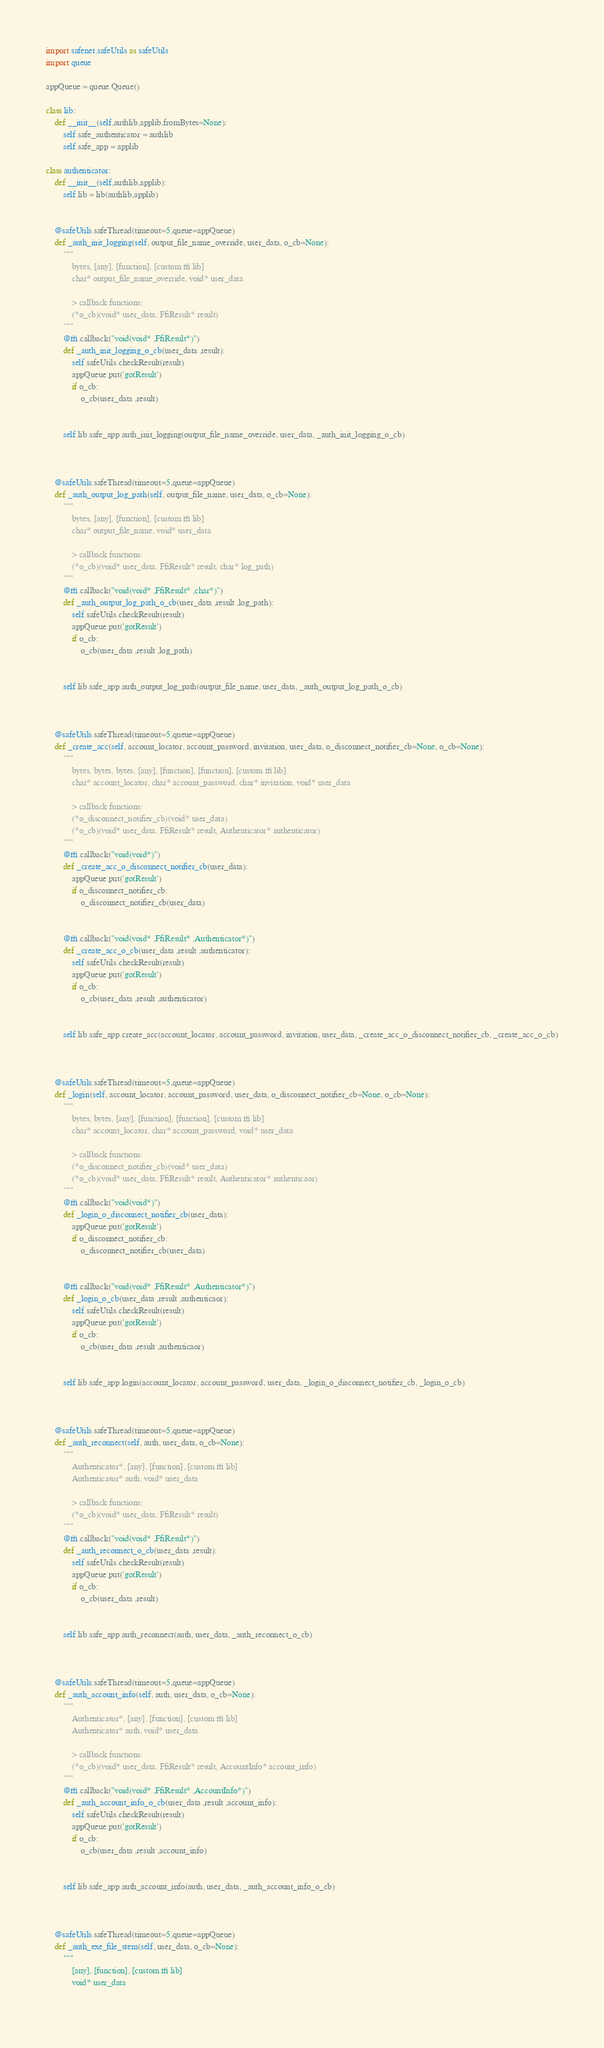<code> <loc_0><loc_0><loc_500><loc_500><_Python_>import safenet.safeUtils as safeUtils
import queue

appQueue = queue.Queue()

class lib:
    def __init__(self,authlib,applib,fromBytes=None):
        self.safe_authenticator = authlib
        self.safe_app = applib

class authenticator:
    def __init__(self,authlib,applib):
        self.lib = lib(authlib,applib)


    @safeUtils.safeThread(timeout=5,queue=appQueue)
    def _auth_init_logging(self, output_file_name_override, user_data, o_cb=None):
        """
            bytes, [any], [function], [custom ffi lib]
            char* output_file_name_override, void* user_data
    
            > callback functions:
            (*o_cb)(void* user_data, FfiResult* result)
        """
        @ffi.callback("void(void* ,FfiResult*)")
        def _auth_init_logging_o_cb(user_data ,result):
            self.safeUtils.checkResult(result)
            appQueue.put('gotResult')
            if o_cb:
                o_cb(user_data ,result)
    
    
        self.lib.safe_app.auth_init_logging(output_file_name_override, user_data, _auth_init_logging_o_cb)
    
    
    
    @safeUtils.safeThread(timeout=5,queue=appQueue)
    def _auth_output_log_path(self, output_file_name, user_data, o_cb=None):
        """
            bytes, [any], [function], [custom ffi lib]
            char* output_file_name, void* user_data
    
            > callback functions:
            (*o_cb)(void* user_data, FfiResult* result, char* log_path)
        """
        @ffi.callback("void(void* ,FfiResult* ,char*)")
        def _auth_output_log_path_o_cb(user_data ,result ,log_path):
            self.safeUtils.checkResult(result)
            appQueue.put('gotResult')
            if o_cb:
                o_cb(user_data ,result ,log_path)
    
    
        self.lib.safe_app.auth_output_log_path(output_file_name, user_data, _auth_output_log_path_o_cb)
    
    
    
    @safeUtils.safeThread(timeout=5,queue=appQueue)
    def _create_acc(self, account_locator, account_password, invitation, user_data, o_disconnect_notifier_cb=None, o_cb=None):
        """
            bytes, bytes, bytes, [any], [function], [function], [custom ffi lib]
            char* account_locator, char* account_password, char* invitation, void* user_data
    
            > callback functions:
            (*o_disconnect_notifier_cb)(void* user_data)
            (*o_cb)(void* user_data, FfiResult* result, Authenticator* authenticator)
        """
        @ffi.callback("void(void*)")
        def _create_acc_o_disconnect_notifier_cb(user_data):
            appQueue.put('gotResult')
            if o_disconnect_notifier_cb:
                o_disconnect_notifier_cb(user_data)
    
    
        @ffi.callback("void(void* ,FfiResult* ,Authenticator*)")
        def _create_acc_o_cb(user_data ,result ,authenticator):
            self.safeUtils.checkResult(result)
            appQueue.put('gotResult')
            if o_cb:
                o_cb(user_data ,result ,authenticator)
    
    
        self.lib.safe_app.create_acc(account_locator, account_password, invitation, user_data, _create_acc_o_disconnect_notifier_cb, _create_acc_o_cb)
    
    
    
    @safeUtils.safeThread(timeout=5,queue=appQueue)
    def _login(self, account_locator, account_password, user_data, o_disconnect_notifier_cb=None, o_cb=None):
        """
            bytes, bytes, [any], [function], [function], [custom ffi lib]
            char* account_locator, char* account_password, void* user_data
    
            > callback functions:
            (*o_disconnect_notifier_cb)(void* user_data)
            (*o_cb)(void* user_data, FfiResult* result, Authenticator* authenticaor)
        """
        @ffi.callback("void(void*)")
        def _login_o_disconnect_notifier_cb(user_data):
            appQueue.put('gotResult')
            if o_disconnect_notifier_cb:
                o_disconnect_notifier_cb(user_data)
    
    
        @ffi.callback("void(void* ,FfiResult* ,Authenticator*)")
        def _login_o_cb(user_data ,result ,authenticaor):
            self.safeUtils.checkResult(result)
            appQueue.put('gotResult')
            if o_cb:
                o_cb(user_data ,result ,authenticaor)
    
    
        self.lib.safe_app.login(account_locator, account_password, user_data, _login_o_disconnect_notifier_cb, _login_o_cb)
    
    
    
    @safeUtils.safeThread(timeout=5,queue=appQueue)
    def _auth_reconnect(self, auth, user_data, o_cb=None):
        """
            Authenticator*, [any], [function], [custom ffi lib]
            Authenticator* auth, void* user_data
    
            > callback functions:
            (*o_cb)(void* user_data, FfiResult* result)
        """
        @ffi.callback("void(void* ,FfiResult*)")
        def _auth_reconnect_o_cb(user_data ,result):
            self.safeUtils.checkResult(result)
            appQueue.put('gotResult')
            if o_cb:
                o_cb(user_data ,result)
    
    
        self.lib.safe_app.auth_reconnect(auth, user_data, _auth_reconnect_o_cb)
    
    
    
    @safeUtils.safeThread(timeout=5,queue=appQueue)
    def _auth_account_info(self, auth, user_data, o_cb=None):
        """
            Authenticator*, [any], [function], [custom ffi lib]
            Authenticator* auth, void* user_data
    
            > callback functions:
            (*o_cb)(void* user_data, FfiResult* result, AccountInfo* account_info)
        """
        @ffi.callback("void(void* ,FfiResult* ,AccountInfo*)")
        def _auth_account_info_o_cb(user_data ,result ,account_info):
            self.safeUtils.checkResult(result)
            appQueue.put('gotResult')
            if o_cb:
                o_cb(user_data ,result ,account_info)
    
    
        self.lib.safe_app.auth_account_info(auth, user_data, _auth_account_info_o_cb)
    
    
    
    @safeUtils.safeThread(timeout=5,queue=appQueue)
    def _auth_exe_file_stem(self, user_data, o_cb=None):
        """
            [any], [function], [custom ffi lib]
            void* user_data
    </code> 